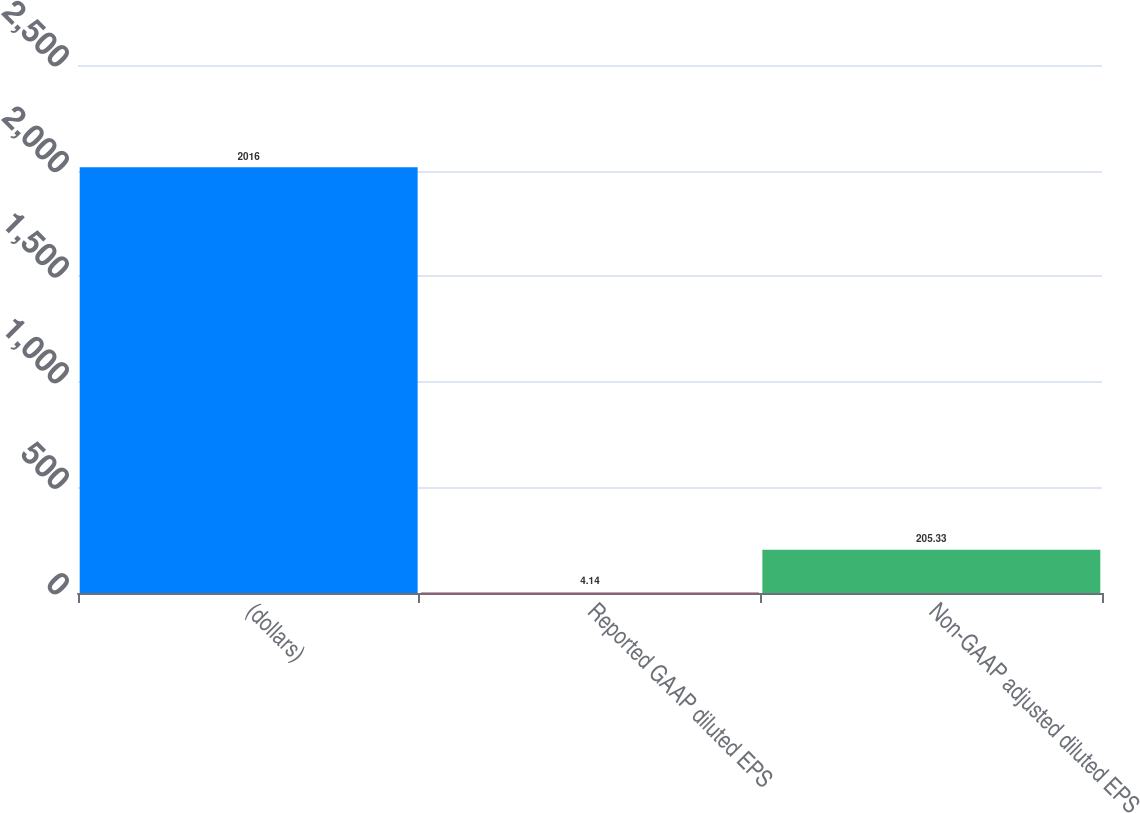Convert chart. <chart><loc_0><loc_0><loc_500><loc_500><bar_chart><fcel>(dollars)<fcel>Reported GAAP diluted EPS<fcel>Non-GAAP adjusted diluted EPS<nl><fcel>2016<fcel>4.14<fcel>205.33<nl></chart> 